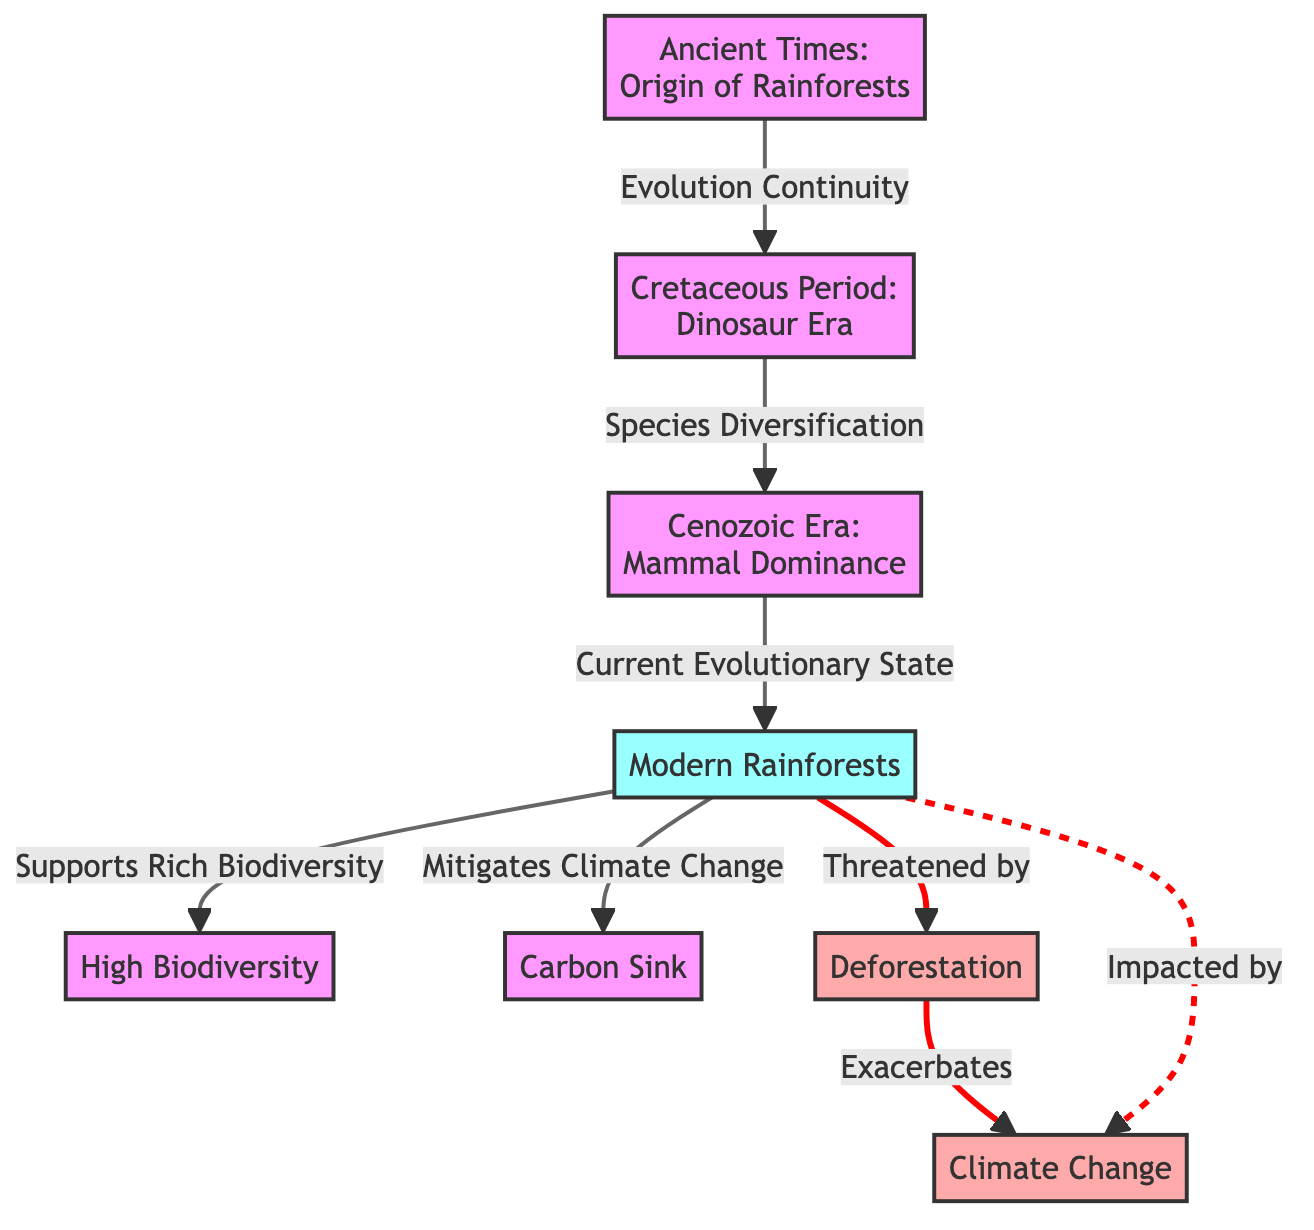What is the first node in the diagram? The first node in the diagram is labeled "Ancient Times: Origin of Rainforests". This is evident as it is the starting point of the flowchart, indicated by its position at the top and the starting arrow pointing to the next node.
Answer: Ancient Times: Origin of Rainforests How many main time periods are represented in the diagram? There are four main time periods represented in the diagram: Ancient Times, Cretaceous Period, Cenozoic Era, and Modern Rainforests. Each of these is a distinct node in the flowchart, confirming their count.
Answer: 4 What relationship exists between the Cretaceous Period and the Cenozoic Era? The relationship is labeled as "Species Diversification", indicating that during the transition from the Cretaceous Period to the Cenozoic Era, species diversified. This is shown by the connecting arrow and accompanying label between these two nodes.
Answer: Species Diversification Which node describes the impact of modern rainforests on climate change? The node that describes the impact of modern rainforests on climate change is labeled "Mitigates Climate Change". This is shown as a direct connection from the Modern Rainforests node with this description.
Answer: Mitigates Climate Change What does modern rainforests support according to the diagram? According to the diagram, modern rainforests support "Rich Biodiversity". This is indicated by the arrow connecting Modern Rainforests to the High Biodiversity node with this label.
Answer: Rich Biodiversity How does deforestation affect climate change based on the diagram? Deforestation is shown to "Exacerbate" climate change according to the diagram. This relationship is drawn with a connecting arrow from the Deforestation node leading to the Climate Change node.
Answer: Exacerbate What is a key feature of modern rainforests? A key feature of modern rainforests, as indicated in the diagram, is that they act as a "Carbon Sink". This is explicitly labeled in the flow from Modern Rainforests to the Carbon Sink node.
Answer: Carbon Sink How are modern rainforests affected by climate change? Modern rainforests are impacted by climate change and this connection is represented by a dashed line with the label "Impacted by" from the Modern Rainforests node to the Climate Change node, indicating a less direct but significant relationship.
Answer: Impacted by What type of ecosystem aspect is represented by a dashed connection? The dashed connection represents a less direct relationship or impact. In this diagram, it is used to illustrate that modern rainforests are impacted by climate change. The use of the dashed line suggests that this is not a straightforward or dominating relationship.
Answer: Impacted by 